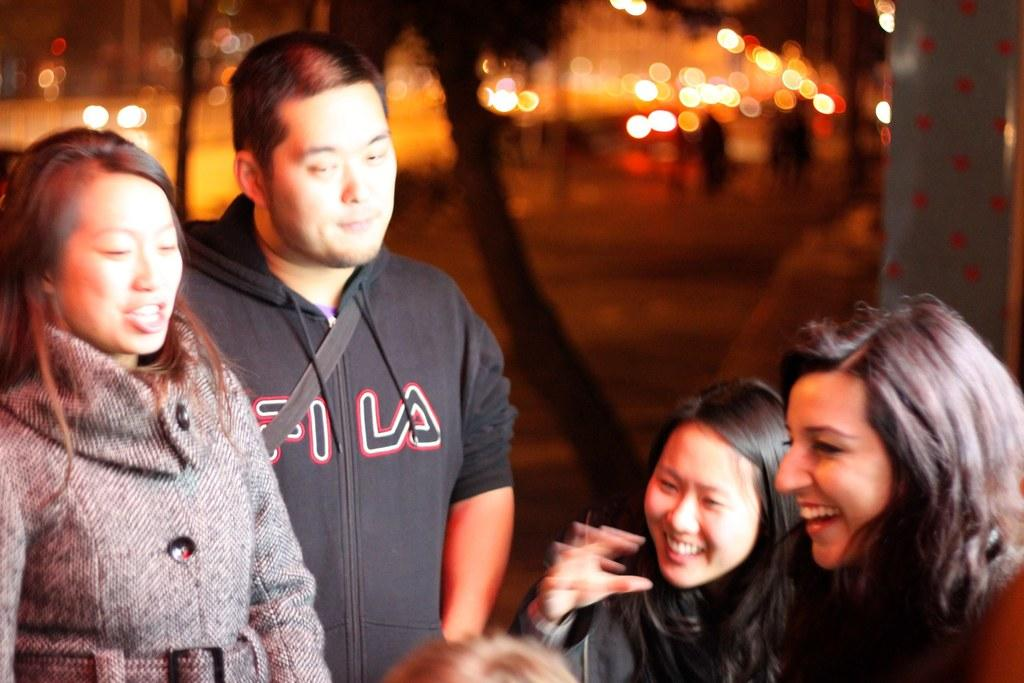How many people are in the image? There are people in the image, but the exact number is not specified. What is the facial expression of some of the people in the image? Some of the people in the image are smiling. What can be seen in the background of the image? There are lights in the background of the image. How would you describe the background of the image? The background of the image is blurred. What type of cake is being served to the people in the image? There is no cake present in the image; it only features people and lights in the background. What is the position of the eggnog in the image? There is no eggnog present in the image. 